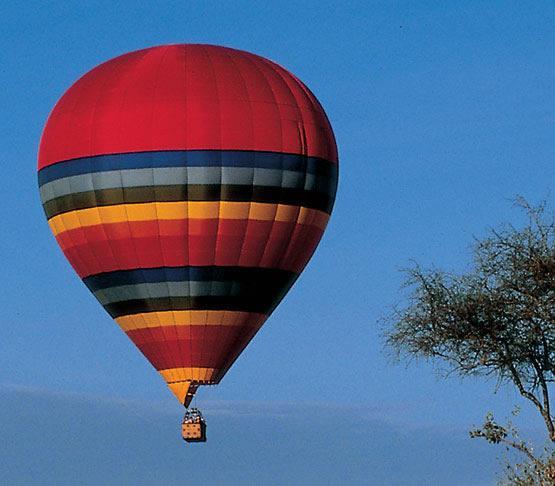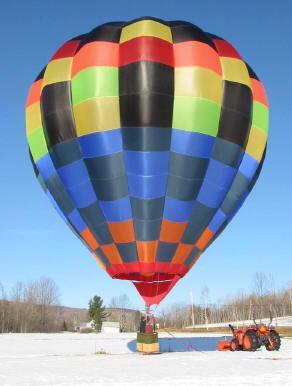The first image is the image on the left, the second image is the image on the right. Assess this claim about the two images: "An image shows the bright light of a flame inside a multi-colored hot-air balloon.". Correct or not? Answer yes or no. No. 